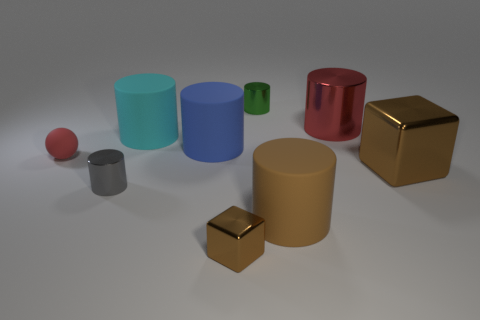Is the small metallic cube the same color as the small matte sphere?
Your answer should be very brief. No. What number of other objects are there of the same material as the big cyan cylinder?
Give a very brief answer. 3. Are there an equal number of green cylinders in front of the tiny red matte object and large green shiny things?
Provide a short and direct response. Yes. Do the rubber thing in front of the red ball and the tiny brown metallic cube have the same size?
Your response must be concise. No. There is a tiny gray metallic cylinder; what number of brown blocks are behind it?
Provide a short and direct response. 1. There is a tiny thing that is on the right side of the red matte sphere and to the left of the big blue cylinder; what is it made of?
Your response must be concise. Metal. How many large objects are red cylinders or matte objects?
Offer a very short reply. 4. What size is the red cylinder?
Offer a very short reply. Large. There is a blue thing; what shape is it?
Your answer should be very brief. Cylinder. Is there anything else that is the same shape as the small red thing?
Provide a succinct answer. No. 